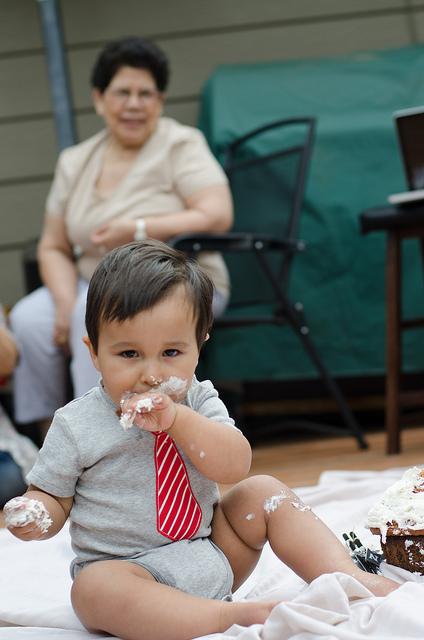What is the boy eating?
Be succinct. Cake. What is around his neck?
Quick response, please. Tie. What color shirt is the boy wearing?
Be succinct. Gray. What is on the child's shirt?
Be succinct. Tie. Is it an indoor scene?
Be succinct. No. Is this family starving?
Quick response, please. No. What does the boy have in his hand?
Be succinct. Cake. Will this child need a bath?
Be succinct. Yes. What color is his shirt?
Give a very brief answer. Gray. Which of the boy's ear is closer to the girls stomach?
Be succinct. Right. What is the little boy doing?
Give a very brief answer. Eating. Is this boy eating with his hands or a fork?
Be succinct. Hands. What color is the baby's diaper?
Concise answer only. Gray. How many fingers do the boy have in his mouth?
Keep it brief. 0. Is this family seated for a formal dinner?
Answer briefly. No. Is the boy in the foreground here?
Keep it brief. Yes. Is this a modern day picture taken with a digital camera?
Short answer required. Yes. What is the baby holding?
Short answer required. Cake. Does the baby's tie match the color of the crate?
Give a very brief answer. No. 